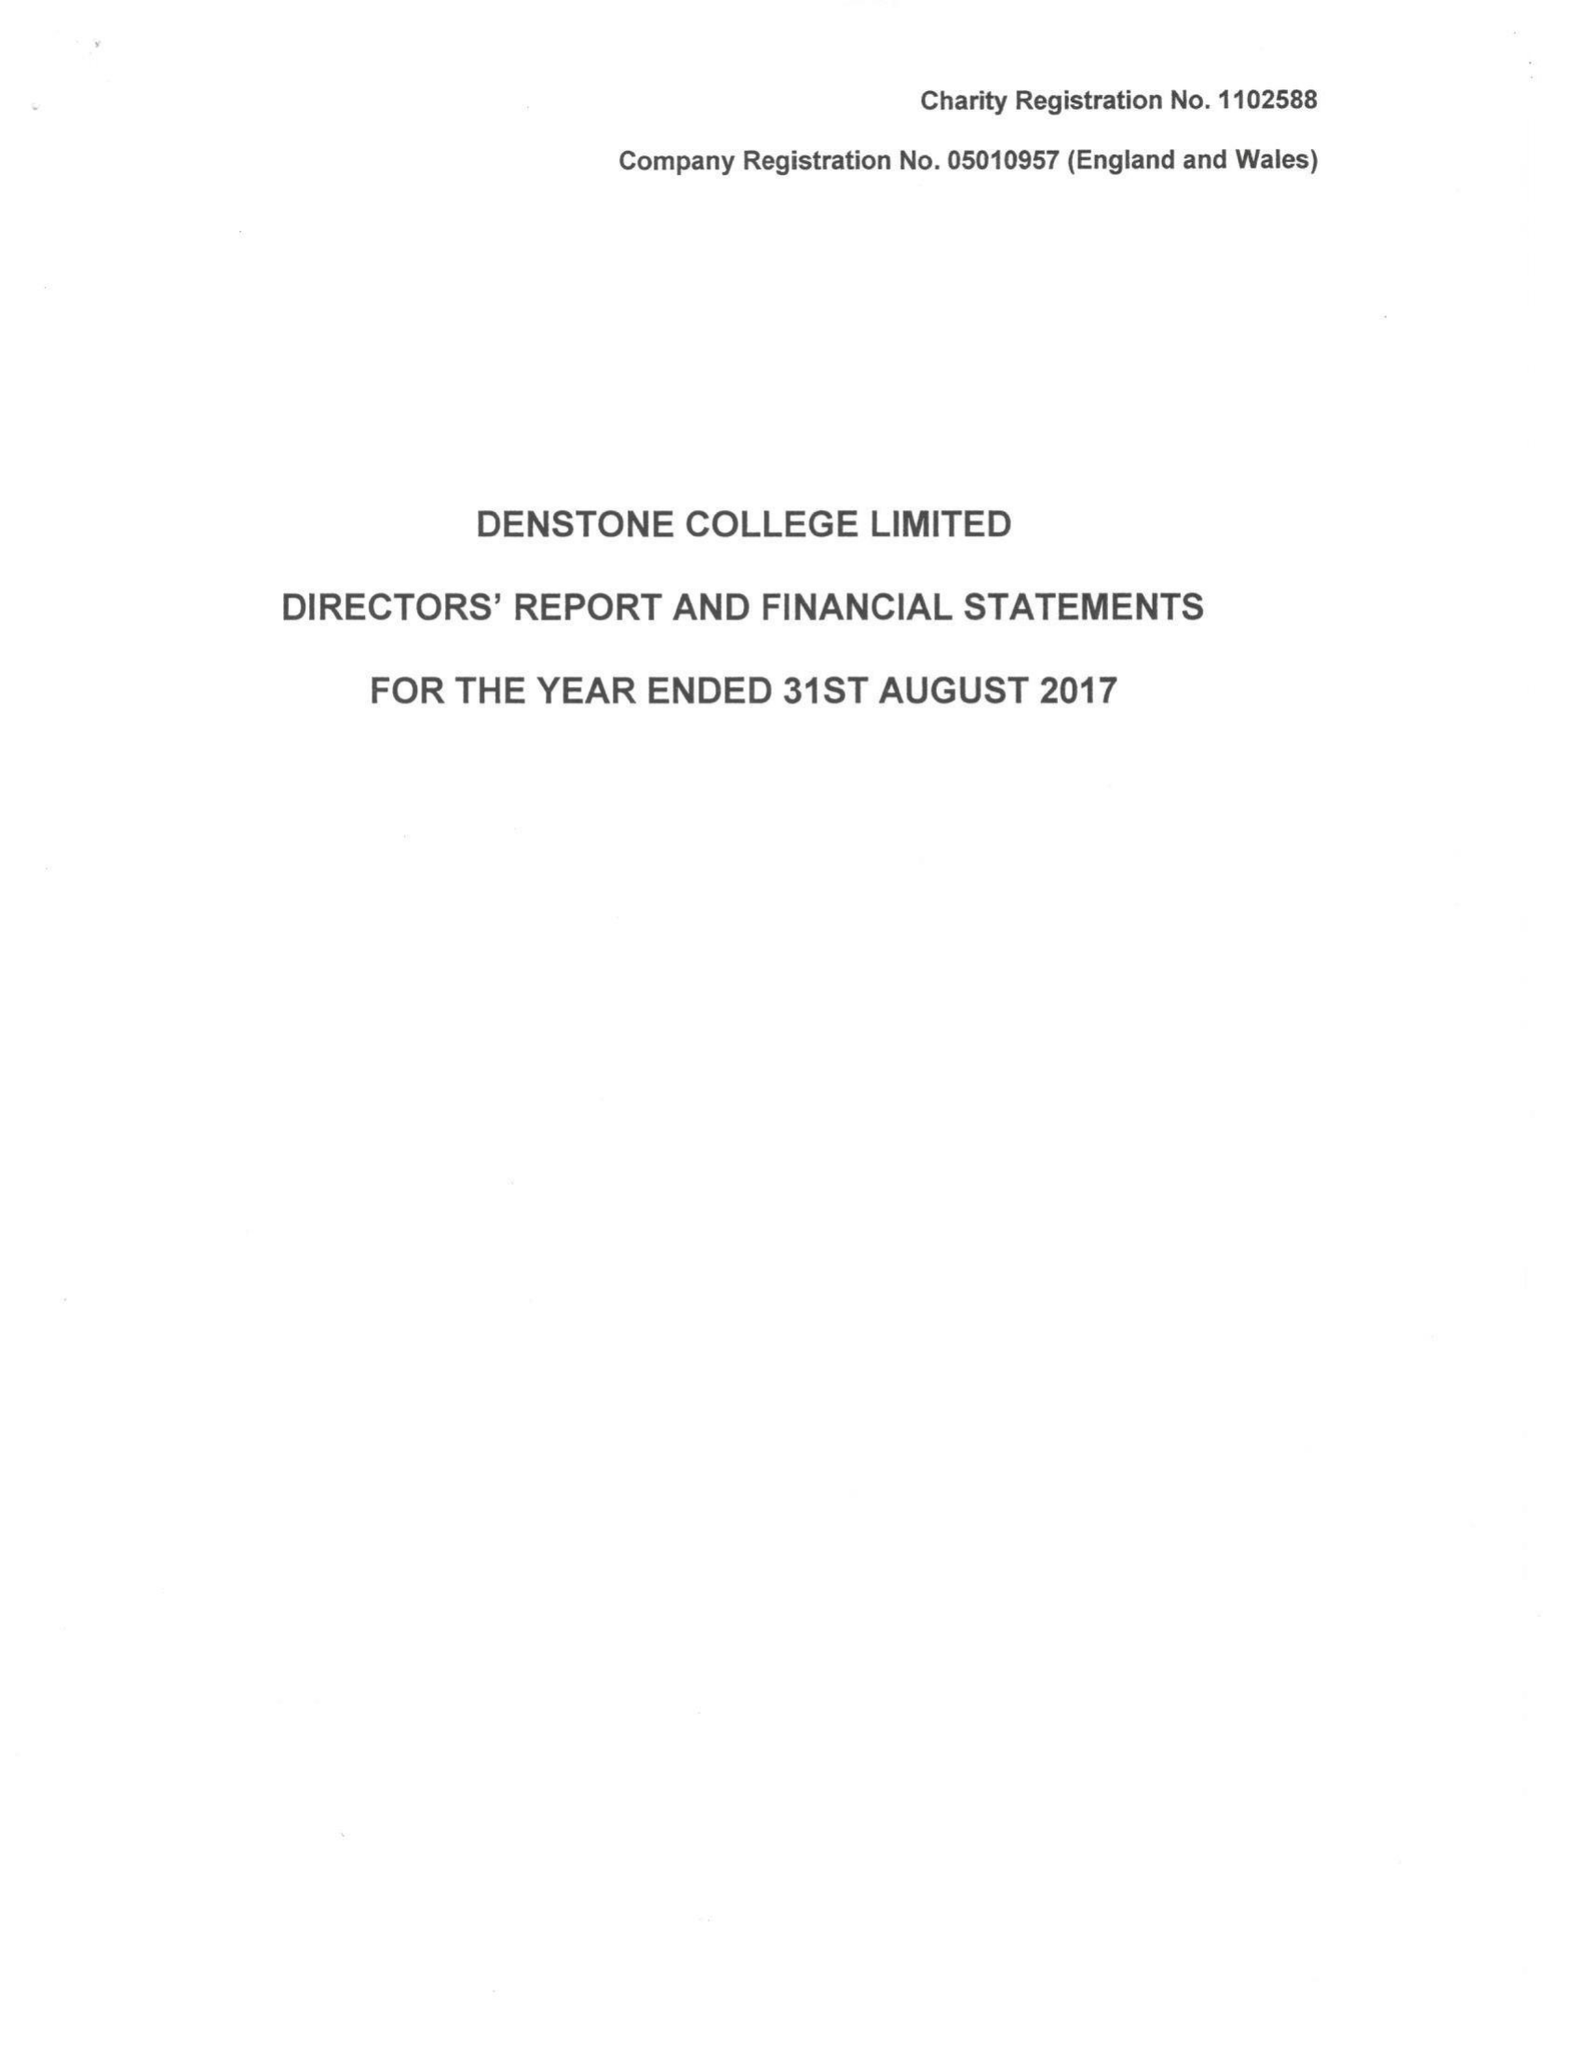What is the value for the spending_annually_in_british_pounds?
Answer the question using a single word or phrase. 9376056.00 